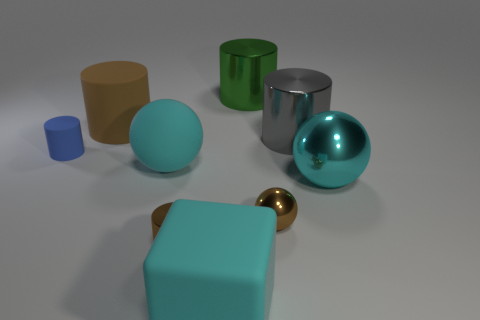What number of balls are the same size as the blue cylinder?
Ensure brevity in your answer.  1. Are there any rubber balls of the same color as the tiny metal cylinder?
Provide a short and direct response. No. Are the big brown thing and the large green object made of the same material?
Keep it short and to the point. No. How many brown things are the same shape as the blue matte thing?
Make the answer very short. 2. There is a large brown object that is the same material as the blue object; what shape is it?
Ensure brevity in your answer.  Cylinder. There is a big shiny cylinder behind the rubber object behind the gray cylinder; what is its color?
Your response must be concise. Green. Is the tiny sphere the same color as the big rubber block?
Provide a succinct answer. No. There is a sphere that is in front of the cyan ball that is in front of the cyan matte sphere; what is it made of?
Your answer should be very brief. Metal. There is a small blue thing that is the same shape as the large green object; what is its material?
Your answer should be very brief. Rubber. There is a rubber cylinder left of the rubber thing that is behind the gray cylinder; are there any big rubber objects in front of it?
Keep it short and to the point. Yes. 